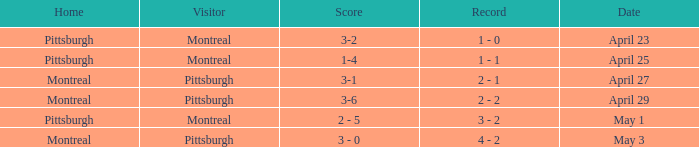When did Montreal visit and have a score of 1-4? April 25. 